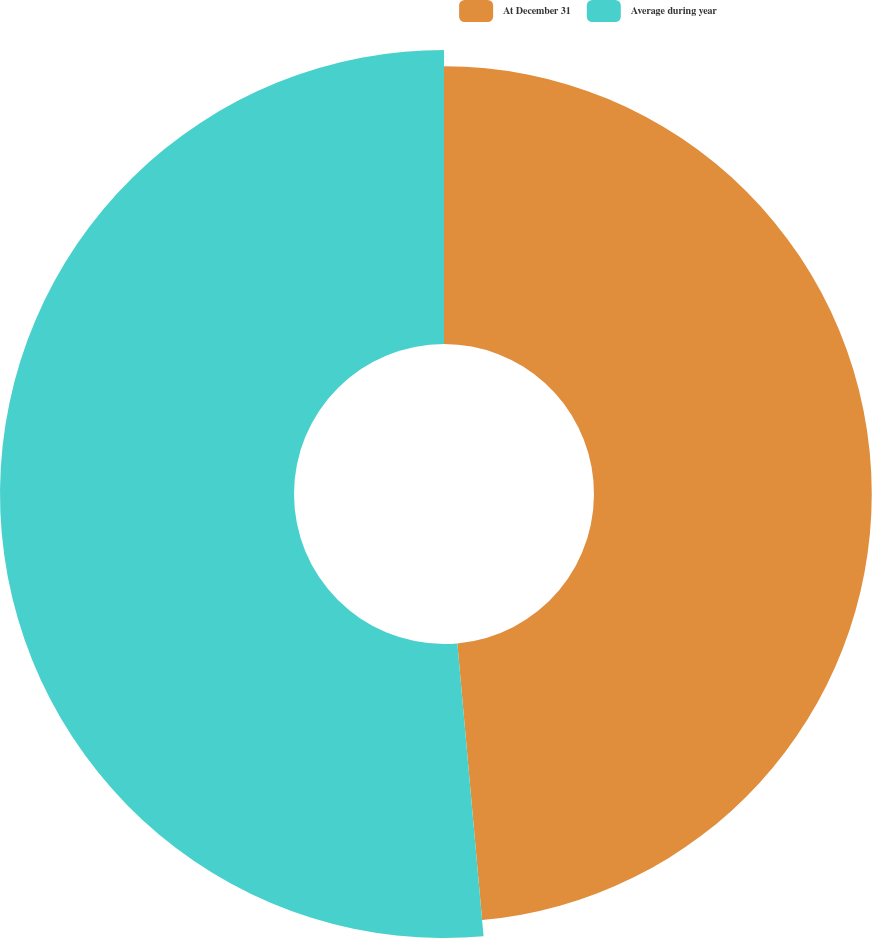Convert chart to OTSL. <chart><loc_0><loc_0><loc_500><loc_500><pie_chart><fcel>At December 31<fcel>Average during year<nl><fcel>48.58%<fcel>51.42%<nl></chart> 